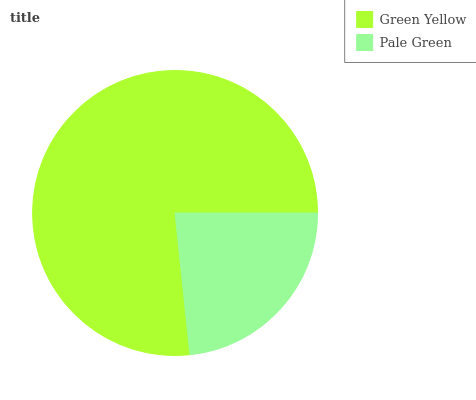Is Pale Green the minimum?
Answer yes or no. Yes. Is Green Yellow the maximum?
Answer yes or no. Yes. Is Pale Green the maximum?
Answer yes or no. No. Is Green Yellow greater than Pale Green?
Answer yes or no. Yes. Is Pale Green less than Green Yellow?
Answer yes or no. Yes. Is Pale Green greater than Green Yellow?
Answer yes or no. No. Is Green Yellow less than Pale Green?
Answer yes or no. No. Is Green Yellow the high median?
Answer yes or no. Yes. Is Pale Green the low median?
Answer yes or no. Yes. Is Pale Green the high median?
Answer yes or no. No. Is Green Yellow the low median?
Answer yes or no. No. 